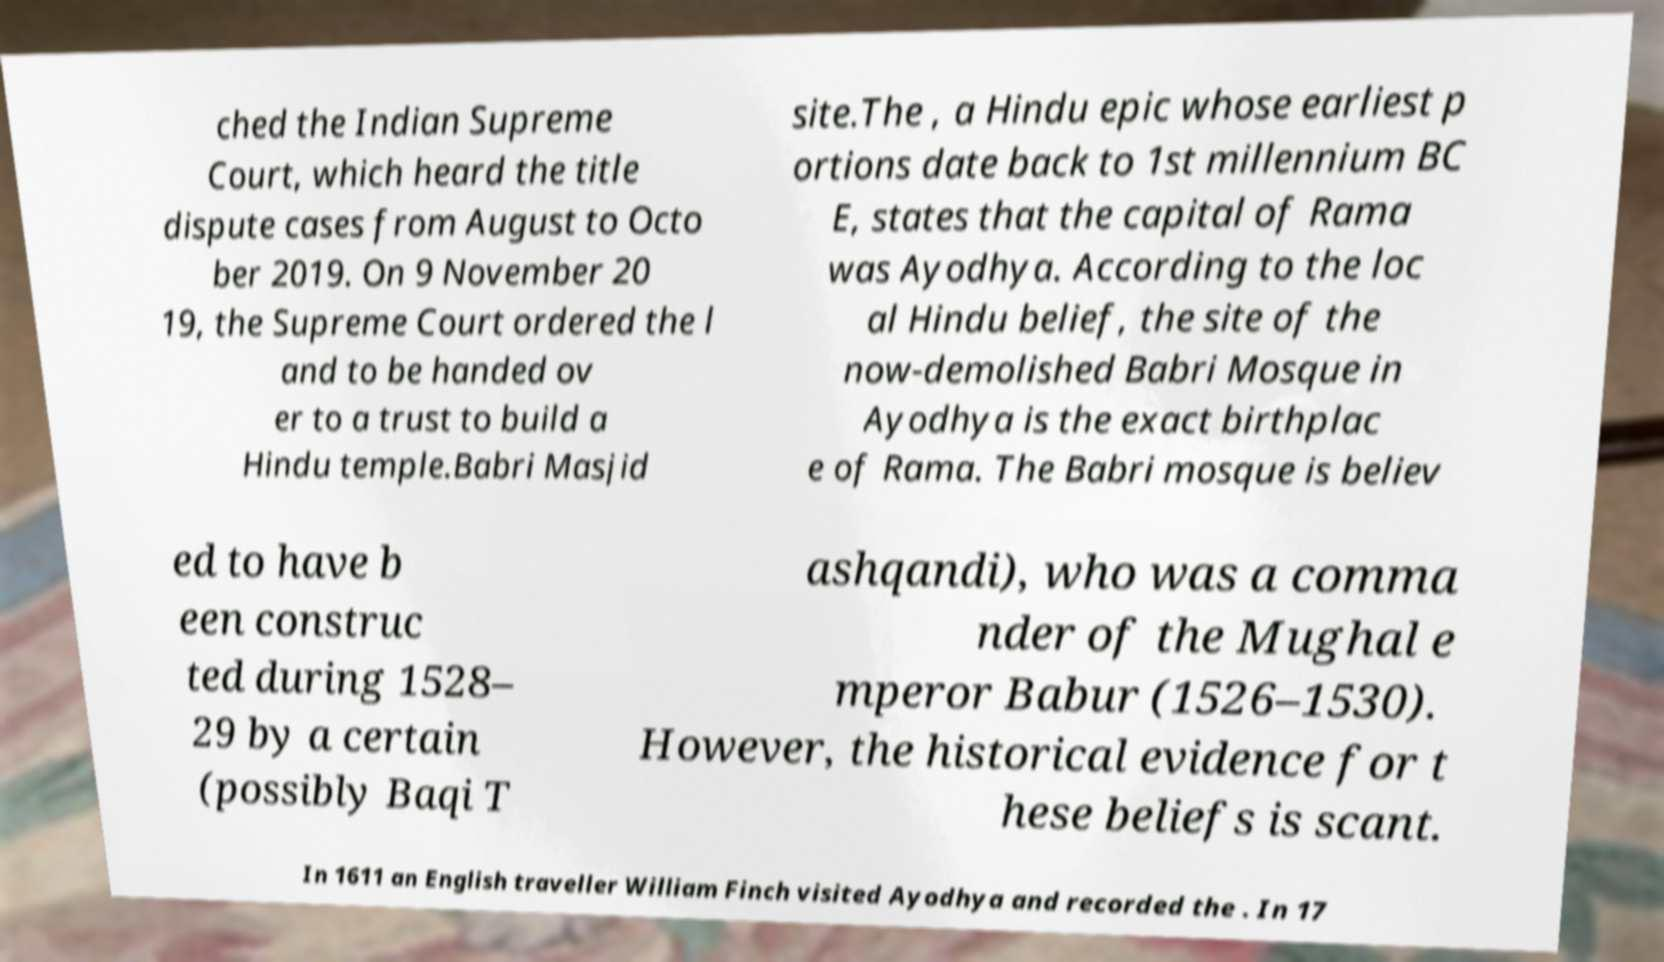Could you extract and type out the text from this image? ched the Indian Supreme Court, which heard the title dispute cases from August to Octo ber 2019. On 9 November 20 19, the Supreme Court ordered the l and to be handed ov er to a trust to build a Hindu temple.Babri Masjid site.The , a Hindu epic whose earliest p ortions date back to 1st millennium BC E, states that the capital of Rama was Ayodhya. According to the loc al Hindu belief, the site of the now-demolished Babri Mosque in Ayodhya is the exact birthplac e of Rama. The Babri mosque is believ ed to have b een construc ted during 1528– 29 by a certain (possibly Baqi T ashqandi), who was a comma nder of the Mughal e mperor Babur (1526–1530). However, the historical evidence for t hese beliefs is scant. In 1611 an English traveller William Finch visited Ayodhya and recorded the . In 17 